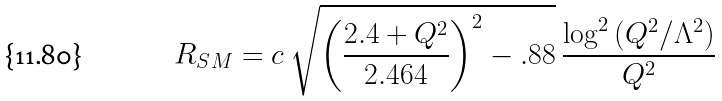<formula> <loc_0><loc_0><loc_500><loc_500>R _ { S M } = c \ \sqrt { \left ( \frac { 2 . 4 + Q ^ { 2 } } { 2 . 4 6 4 } \right ) ^ { 2 } - . 8 8 } \ \frac { \log ^ { 2 } { ( Q ^ { 2 } / \Lambda ^ { 2 } ) } } { Q ^ { 2 } }</formula> 